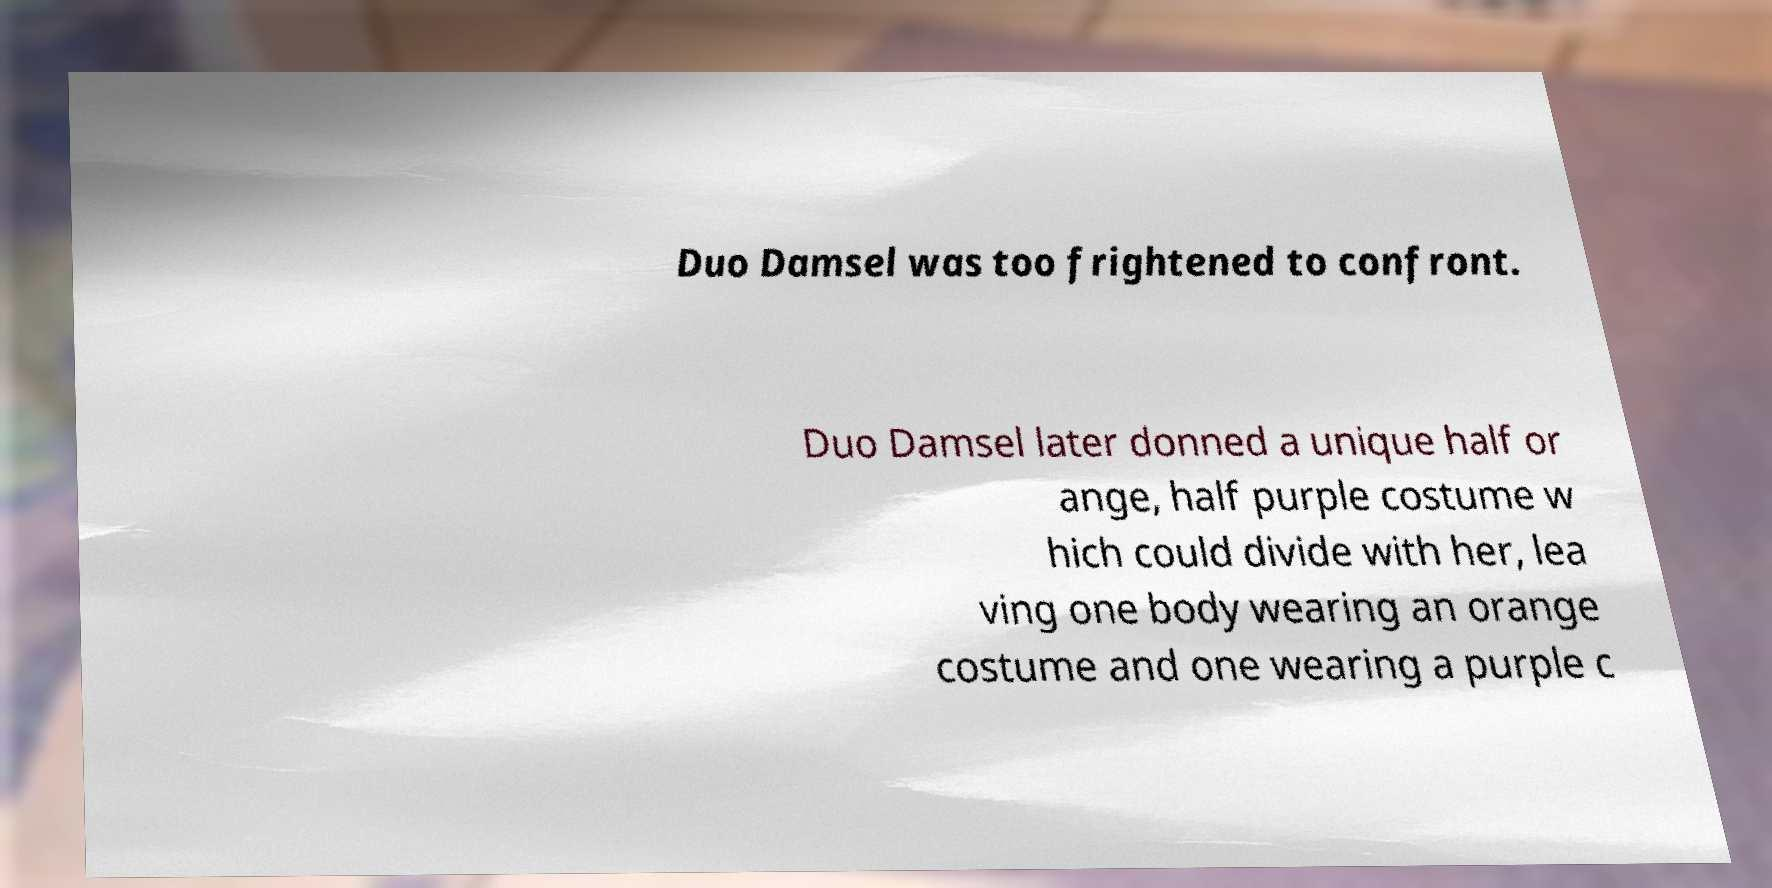Can you read and provide the text displayed in the image?This photo seems to have some interesting text. Can you extract and type it out for me? Duo Damsel was too frightened to confront. Duo Damsel later donned a unique half or ange, half purple costume w hich could divide with her, lea ving one body wearing an orange costume and one wearing a purple c 